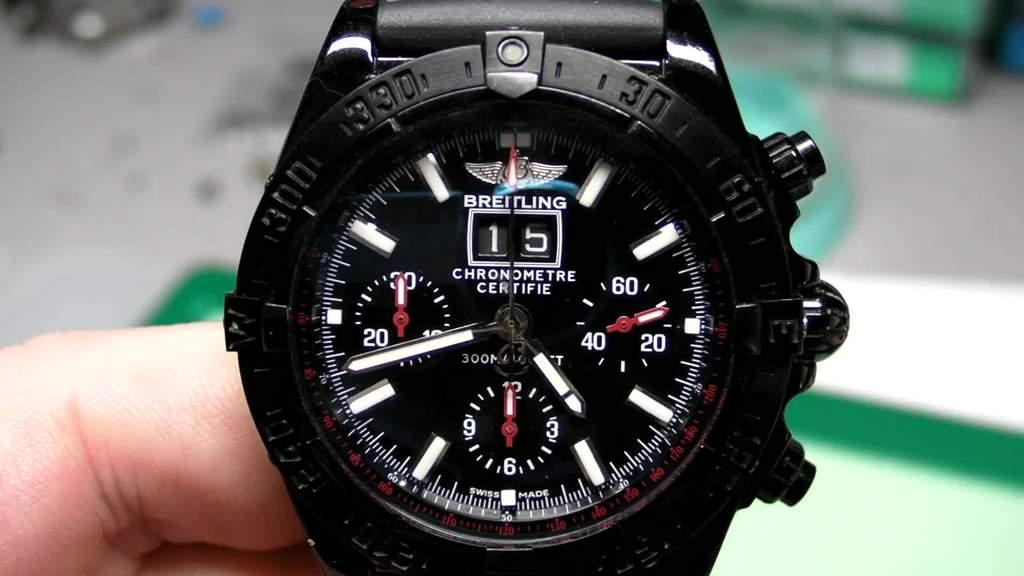<image>
Relay a brief, clear account of the picture shown. A black Breitling watch features yellow and red hands. 